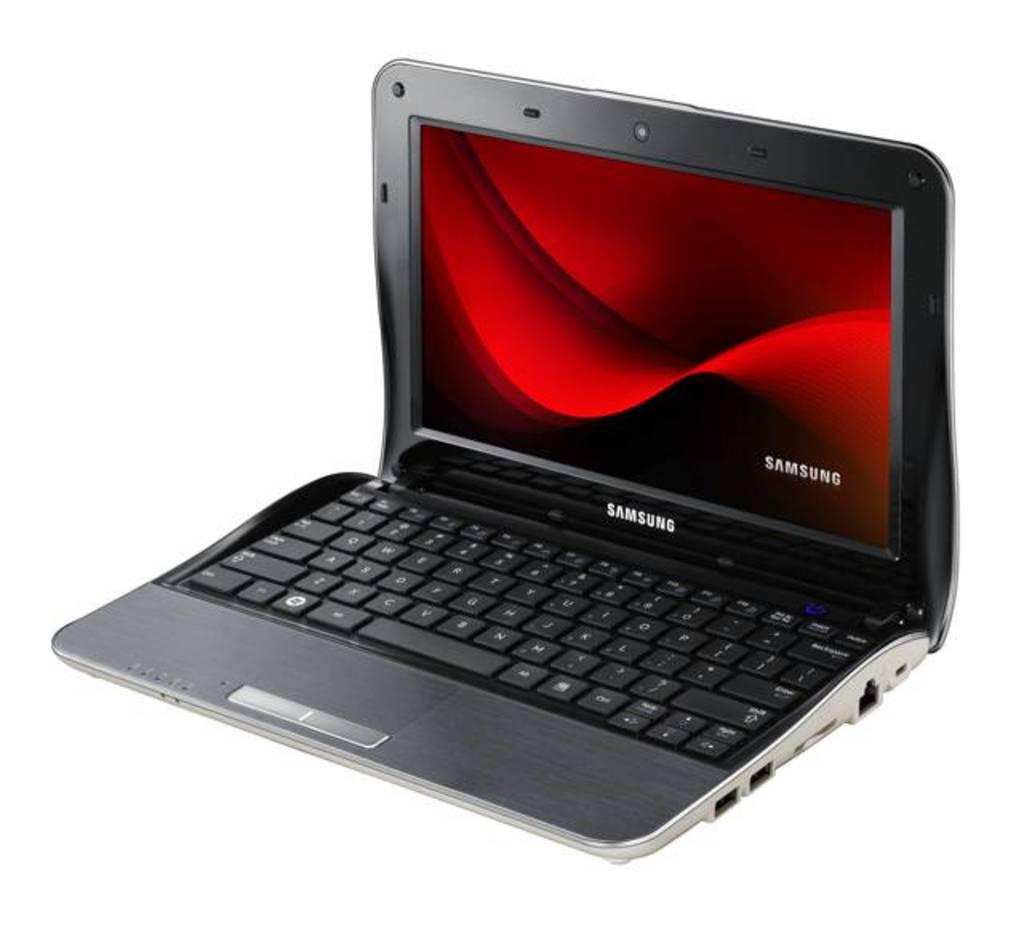<image>
Write a terse but informative summary of the picture. Black Samsung laptop with a red screen on it. 